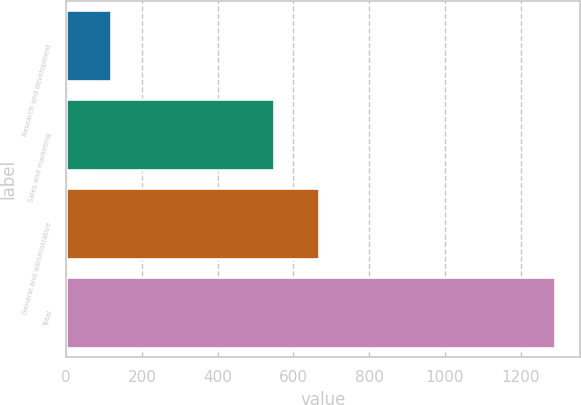Convert chart to OTSL. <chart><loc_0><loc_0><loc_500><loc_500><bar_chart><fcel>Research and development<fcel>Sales and marketing<fcel>General and administrative<fcel>Total<nl><fcel>118<fcel>549<fcel>666.4<fcel>1292<nl></chart> 